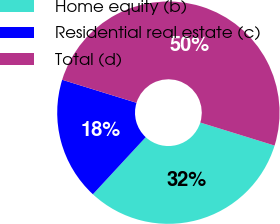<chart> <loc_0><loc_0><loc_500><loc_500><pie_chart><fcel>Home equity (b)<fcel>Residential real estate (c)<fcel>Total (d)<nl><fcel>32.1%<fcel>17.9%<fcel>50.0%<nl></chart> 